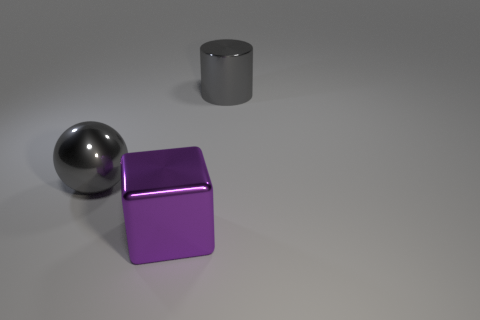Are there an equal number of large gray cylinders on the left side of the large gray metallic cylinder and objects? After inspecting the image, it's evident that there is only one large gray cylinder, so there cannot be an equal number of them on either side of any object, including itself. 